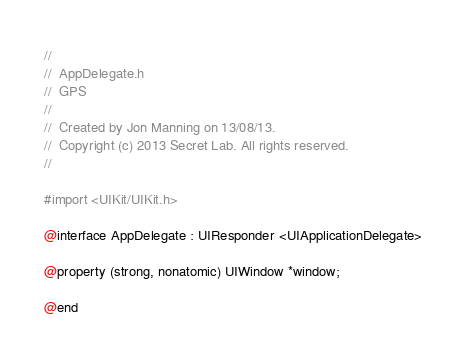<code> <loc_0><loc_0><loc_500><loc_500><_C_>//
//  AppDelegate.h
//  GPS
//
//  Created by Jon Manning on 13/08/13.
//  Copyright (c) 2013 Secret Lab. All rights reserved.
//

#import <UIKit/UIKit.h>

@interface AppDelegate : UIResponder <UIApplicationDelegate>

@property (strong, nonatomic) UIWindow *window;

@end
</code> 